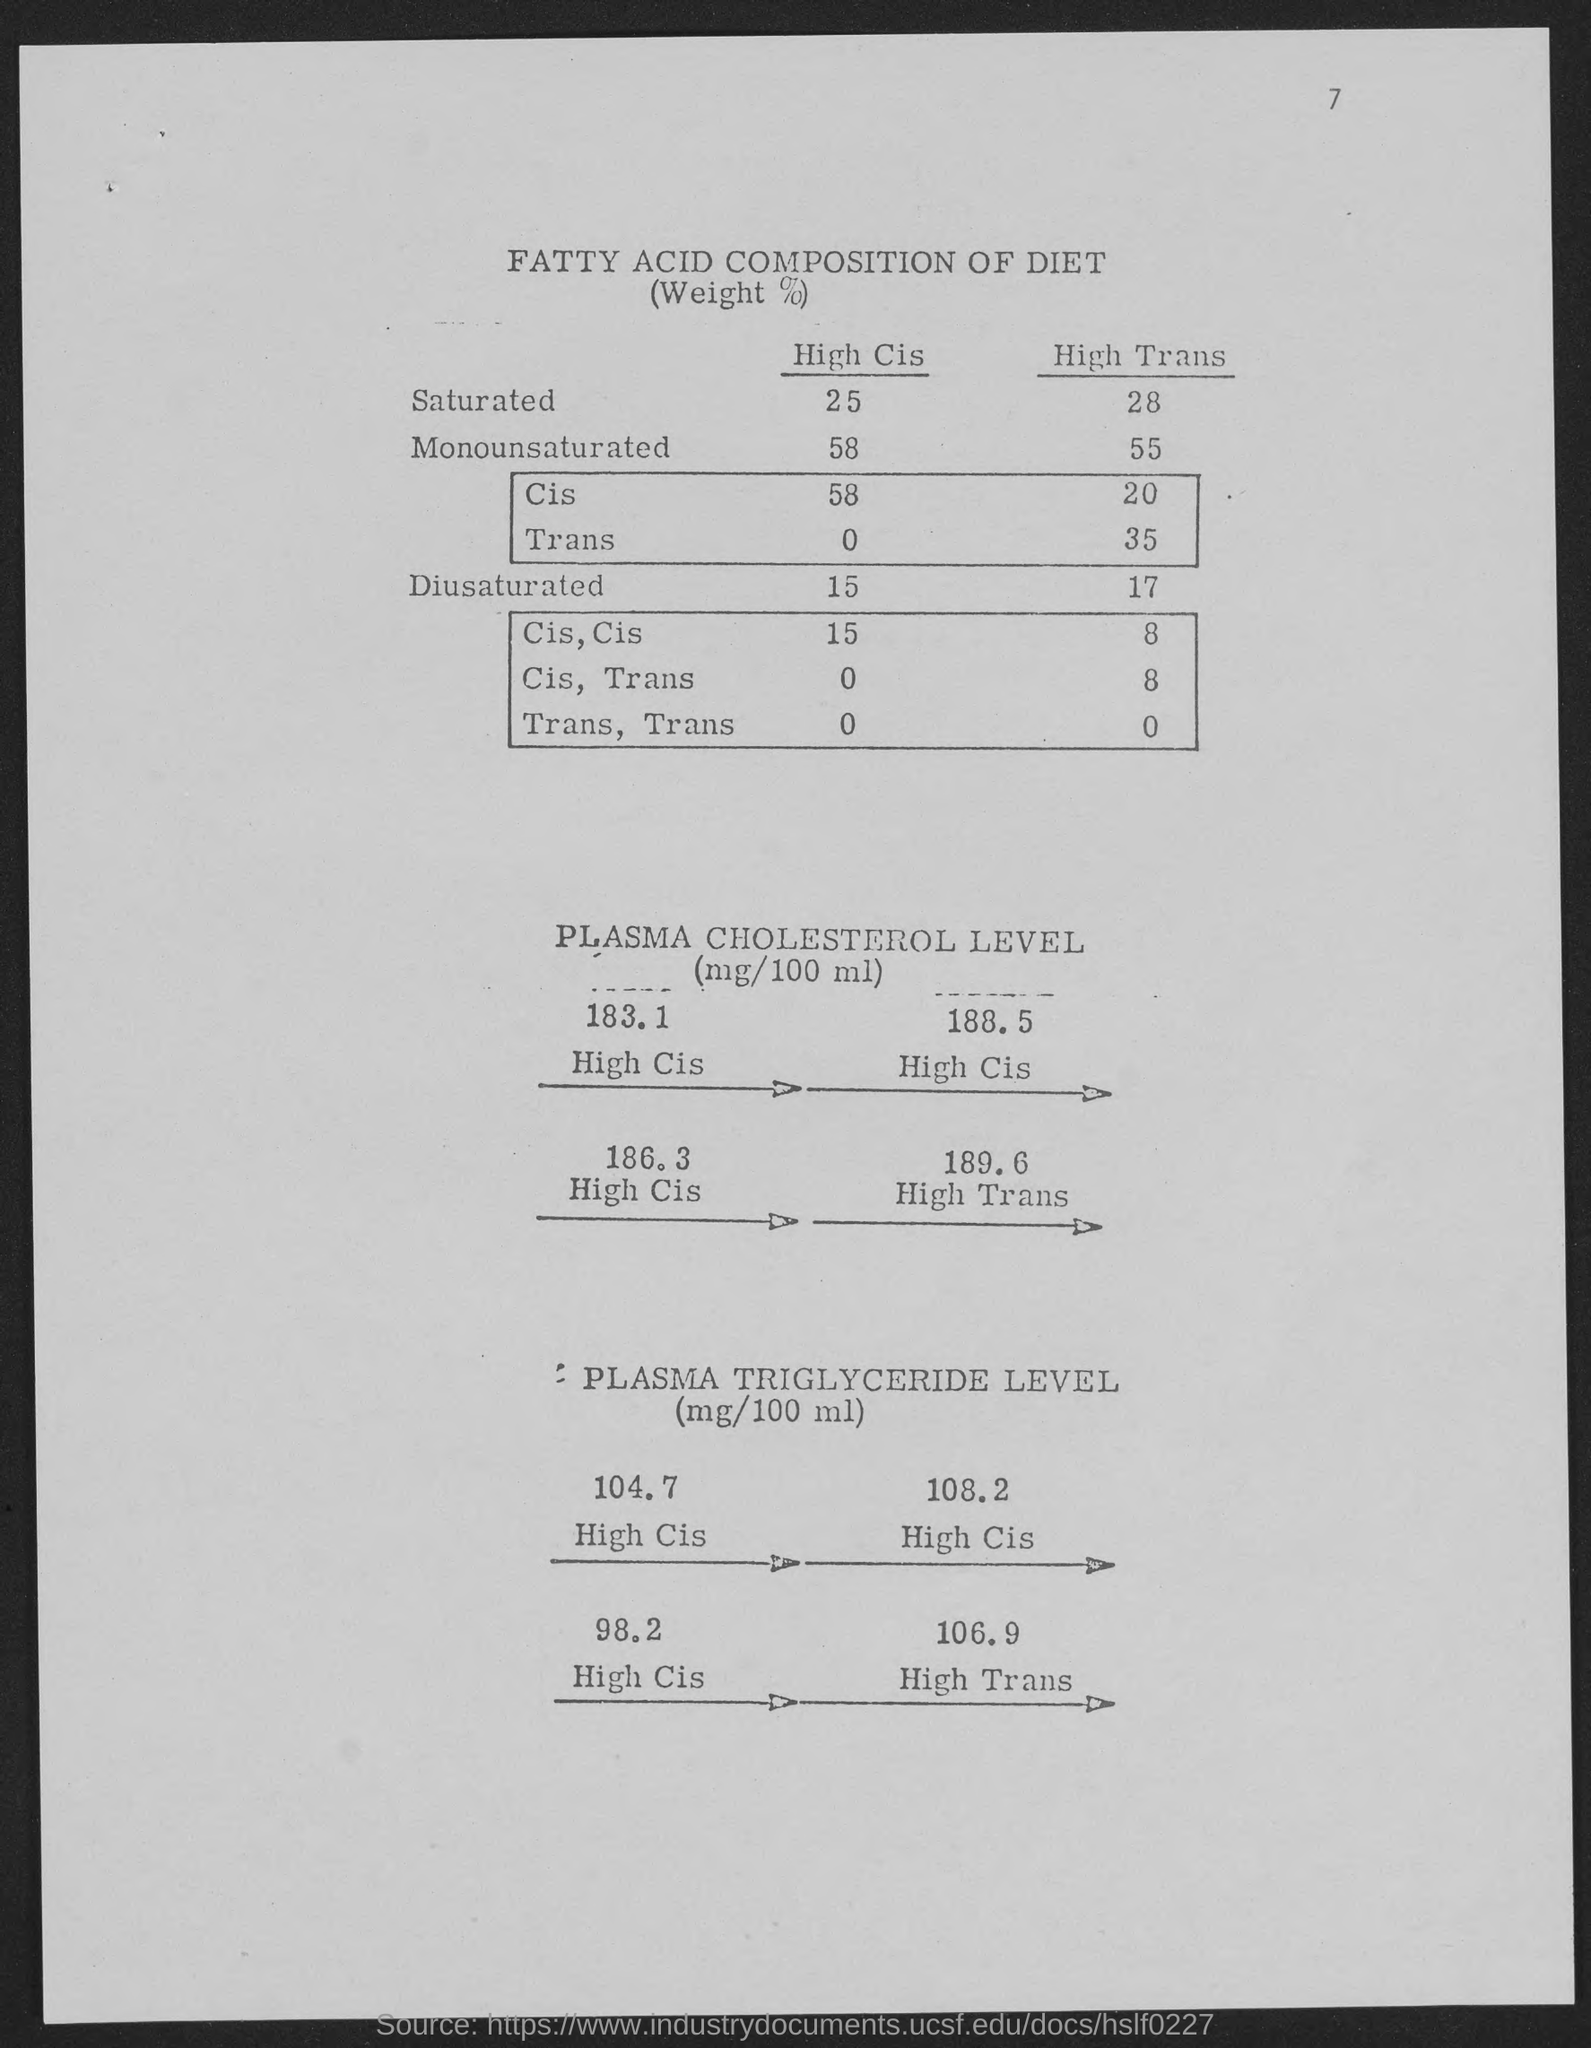Highlight a few significant elements in this photo. High cis-monounsaturated fatty acids are a type of fatty acid that have a single double bond in their molecular structure and are predominantly found in plant-based oils. The term "cis" refers to the arrangement of the double bond in the molecule, while "monounsaturated" indicates that the fatty acid contains only one double bond. The value "58" in the example you provided likely represents a specific concentration or percentage of high cis-monounsaturated fatty acids in a sample or product. The high cis-diol concentration of diesel aromatics is 15%. The High Trans of Monounsaturated is 55. The number located in the top-right corner of the page is 7. The high transmittance of saturated oil at 28 degrees Celsius is [a specific value]. 